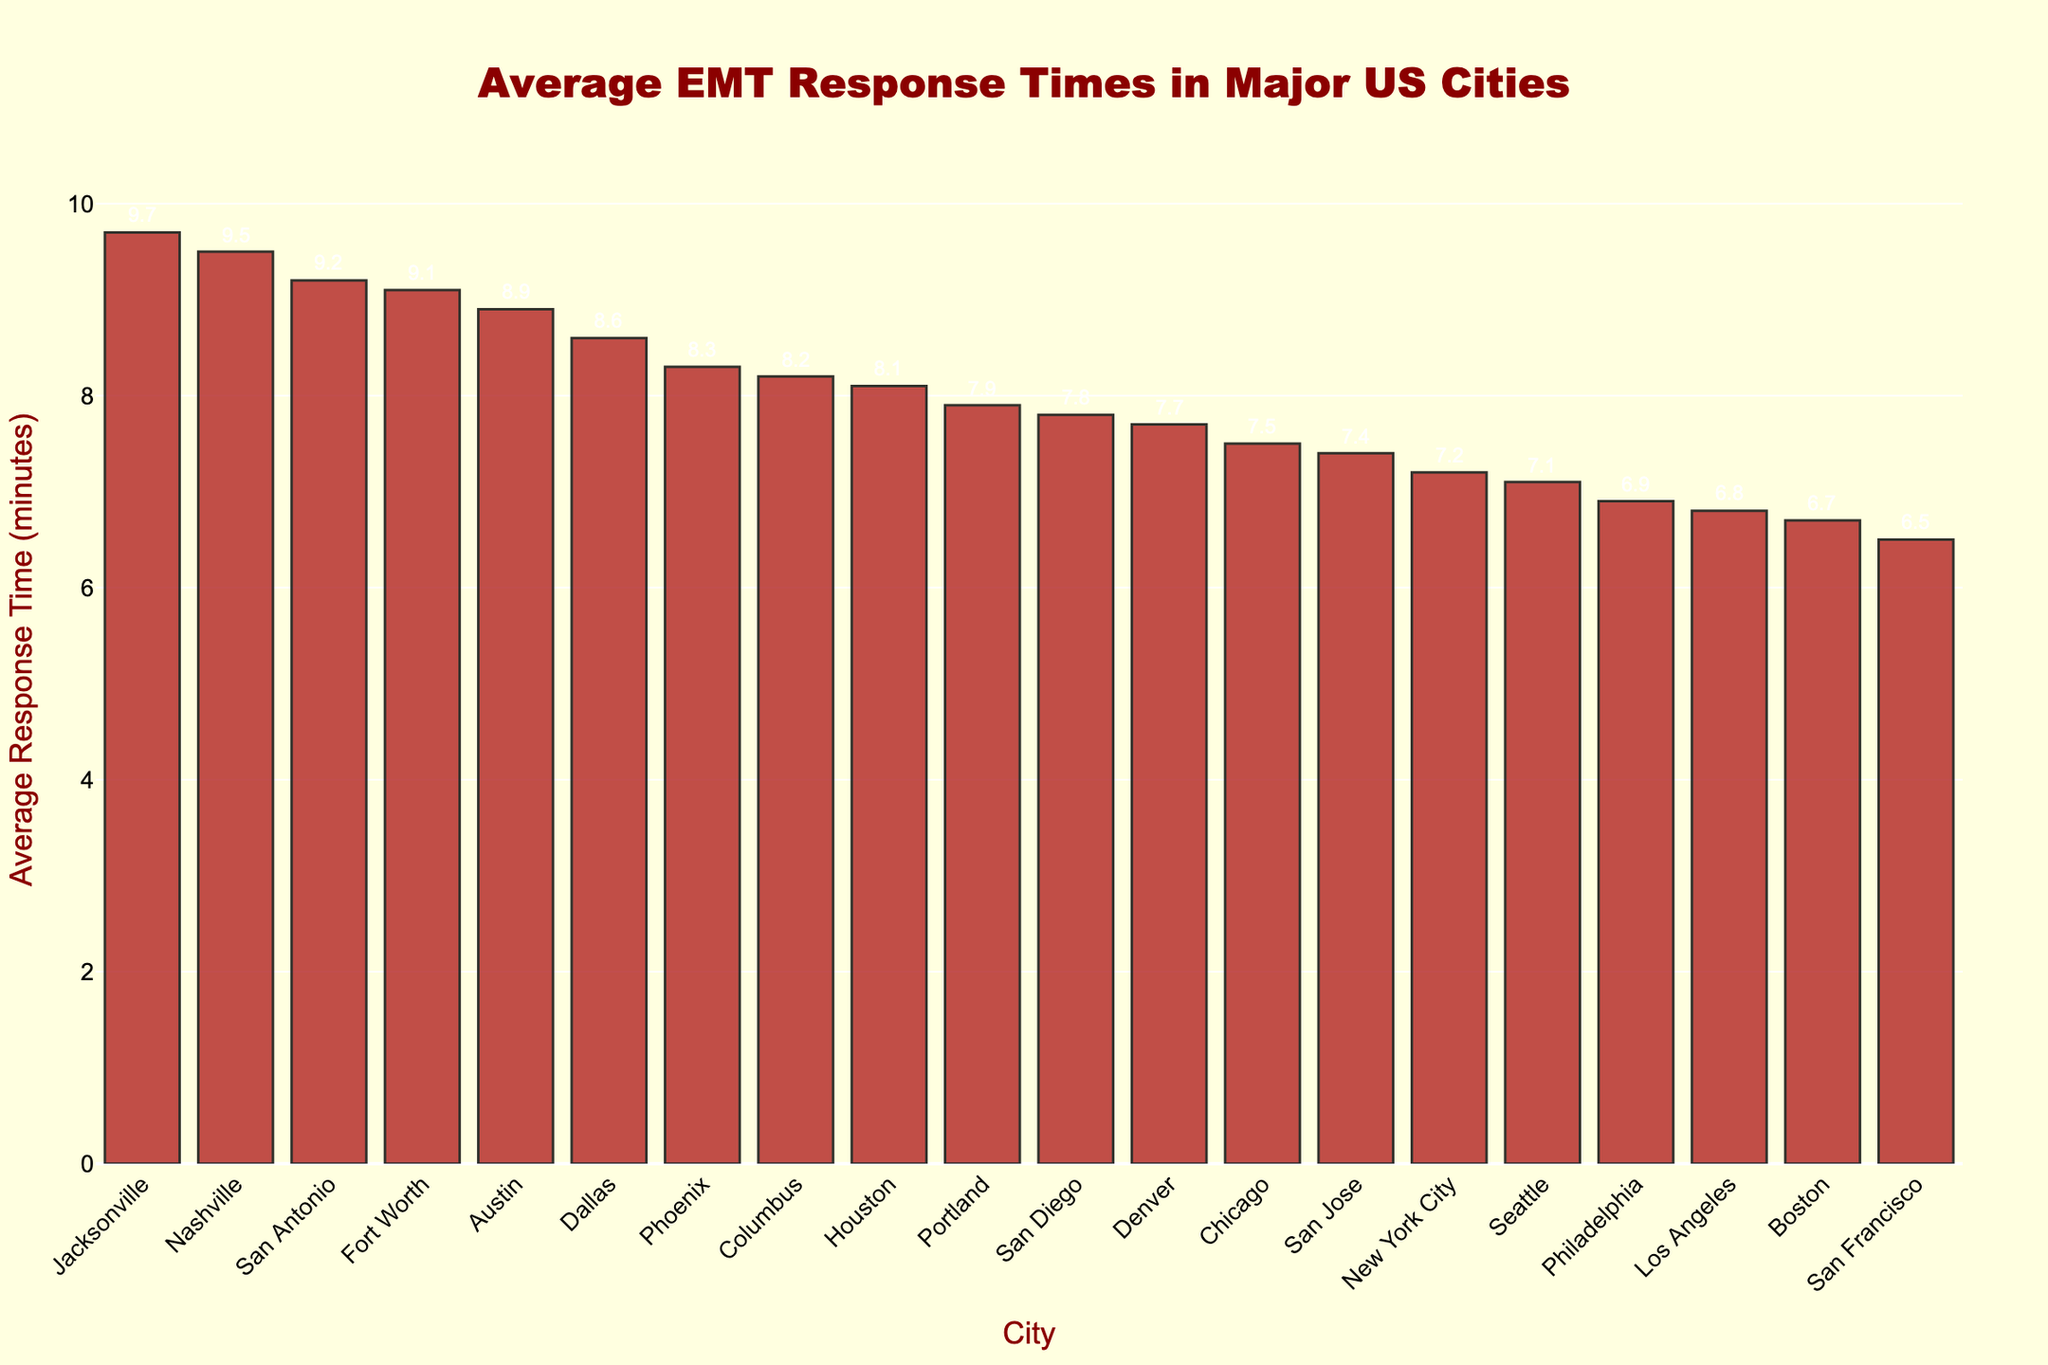What's the city with the highest average EMT response time? By visually inspecting the height of each bar in the chart, Jacksonville has the tallest bar, indicating it has the highest average response time.
Answer: Jacksonville Which city has a lower average EMT response time: Los Angeles or San Francisco? By comparing the heights of the bars for Los Angeles and San Francisco, it's clear that San Francisco's bar is shorter, indicating a lower response time.
Answer: San Francisco What is the difference in average EMT response time between Nashville and Philadelphia? Nashville has an average response time of 9.5 minutes, and Philadelphia has an average response time of 6.9 minutes. The difference is calculated as 9.5 - 6.9.
Answer: 2.6 minutes How many cities have an average EMT response time greater than 8.0 minutes? By counting the cities with bars that extend above the 8.0-minute mark: Houston, Phoenix, San Antonio, Dallas, Austin, Jacksonville, Columbus, Fort Worth, and Nashville. There are nine such cities.
Answer: 9 What's the total average EMT response time for New York City, Chicago, and Boston? The average times for these cities are 7.2 (New York City), 7.5 (Chicago), and 6.7 (Boston). Summing them gives 7.2 + 7.5 + 6.7 = 21.4 minutes.
Answer: 21.4 minutes Which cities have an average EMT response time of less than 7 minutes? These cities include Los Angeles (6.8), Philadelphia (6.9), Boston (6.7), and San Francisco (6.5).
Answer: Los Angeles, Philadelphia, Boston, San Francisco What's the range of average EMT response times in the chart? The highest value is Jacksonville with 9.7 minutes, and the lowest is San Francisco with 6.5 minutes. The range is calculated as 9.7 - 6.5.
Answer: 3.2 minutes What is the average EMT response time across all cities? Sum all the response times: 7.2 + 6.8 + 7.5 + 8.1 + 8.3 + 6.9 + 9.2 + 7.8 + 8.6 + 7.4 + 6.5 + 8.9 + 9.7 + 8.2 + 9.1 + 7.1 + 7.7 + 6.7 + 9.5 + 7.9 = 161.9. Divide by the number of cities (20). The average is 161.9 / 20 = 8.095.
Answer: 8.1 minutes Between Columbus and Denver, which city has a higher average EMT response time and what is the difference? Columbus has an average time of 8.2 and Denver has 7.7. Columbus has a higher time. The difference is 8.2 - 7.7.
Answer: Columbus, 0.5 minutes What are the cities with an average EMT response time between 8.0 and 8.5 minutes? The cities with times in this range are Houston (8.1), Phoenix (8.3), and Columbus (8.2).
Answer: Houston, Phoenix, Columbus 